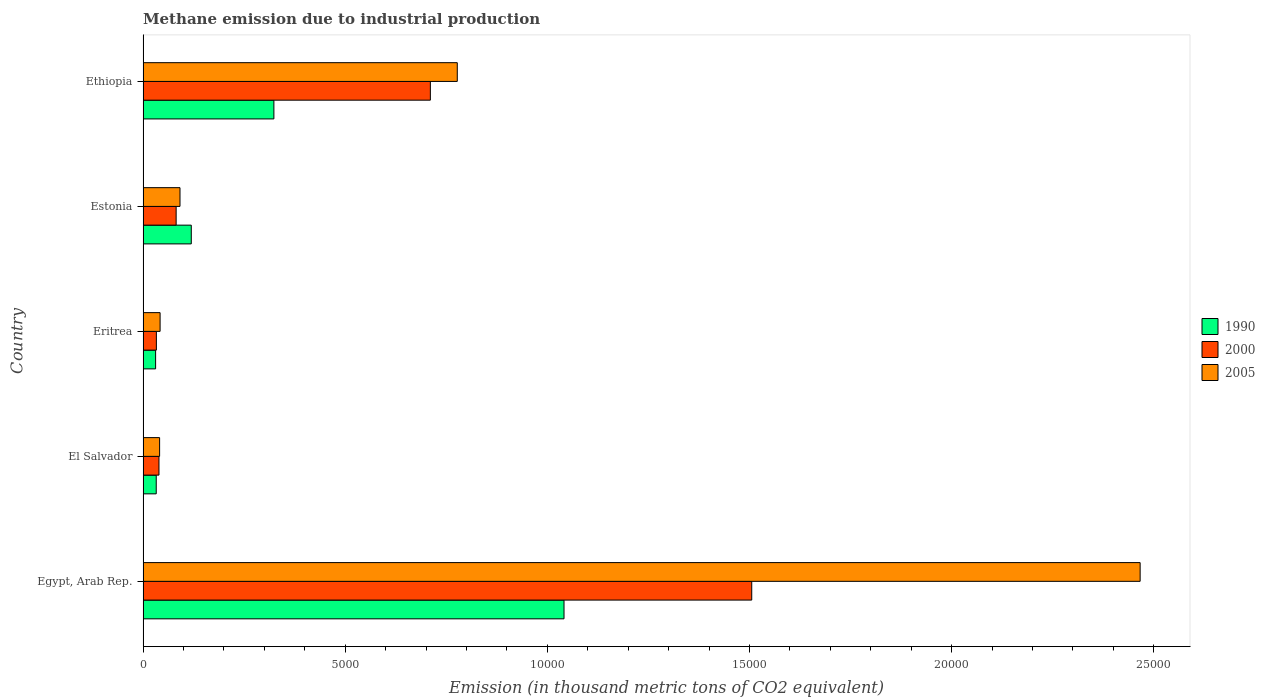How many groups of bars are there?
Your answer should be compact. 5. How many bars are there on the 4th tick from the top?
Offer a very short reply. 3. What is the label of the 4th group of bars from the top?
Provide a short and direct response. El Salvador. In how many cases, is the number of bars for a given country not equal to the number of legend labels?
Make the answer very short. 0. What is the amount of methane emitted in 2000 in Ethiopia?
Offer a very short reply. 7106. Across all countries, what is the maximum amount of methane emitted in 2000?
Provide a succinct answer. 1.51e+04. Across all countries, what is the minimum amount of methane emitted in 2000?
Your answer should be compact. 329.4. In which country was the amount of methane emitted in 1990 maximum?
Provide a short and direct response. Egypt, Arab Rep. In which country was the amount of methane emitted in 2005 minimum?
Offer a very short reply. El Salvador. What is the total amount of methane emitted in 2005 in the graph?
Your response must be concise. 3.42e+04. What is the difference between the amount of methane emitted in 2000 in Egypt, Arab Rep. and that in Eritrea?
Give a very brief answer. 1.47e+04. What is the difference between the amount of methane emitted in 2005 in El Salvador and the amount of methane emitted in 1990 in Eritrea?
Your response must be concise. 98.9. What is the average amount of methane emitted in 1990 per country?
Give a very brief answer. 3095.38. What is the difference between the amount of methane emitted in 2000 and amount of methane emitted in 1990 in Eritrea?
Provide a succinct answer. 19. In how many countries, is the amount of methane emitted in 2000 greater than 19000 thousand metric tons?
Provide a short and direct response. 0. What is the ratio of the amount of methane emitted in 2005 in Egypt, Arab Rep. to that in Eritrea?
Your answer should be compact. 58.52. What is the difference between the highest and the second highest amount of methane emitted in 2000?
Offer a terse response. 7948.9. What is the difference between the highest and the lowest amount of methane emitted in 1990?
Provide a succinct answer. 1.01e+04. In how many countries, is the amount of methane emitted in 2000 greater than the average amount of methane emitted in 2000 taken over all countries?
Your answer should be compact. 2. Is the sum of the amount of methane emitted in 2000 in Egypt, Arab Rep. and Eritrea greater than the maximum amount of methane emitted in 2005 across all countries?
Provide a short and direct response. No. What does the 1st bar from the top in Ethiopia represents?
Ensure brevity in your answer.  2005. Is it the case that in every country, the sum of the amount of methane emitted in 2000 and amount of methane emitted in 2005 is greater than the amount of methane emitted in 1990?
Provide a succinct answer. Yes. How many bars are there?
Your response must be concise. 15. Are all the bars in the graph horizontal?
Give a very brief answer. Yes. Are the values on the major ticks of X-axis written in scientific E-notation?
Your response must be concise. No. Does the graph contain any zero values?
Provide a succinct answer. No. Does the graph contain grids?
Offer a terse response. No. How are the legend labels stacked?
Keep it short and to the point. Vertical. What is the title of the graph?
Offer a terse response. Methane emission due to industrial production. What is the label or title of the X-axis?
Keep it short and to the point. Emission (in thousand metric tons of CO2 equivalent). What is the label or title of the Y-axis?
Keep it short and to the point. Country. What is the Emission (in thousand metric tons of CO2 equivalent) in 1990 in Egypt, Arab Rep.?
Your answer should be very brief. 1.04e+04. What is the Emission (in thousand metric tons of CO2 equivalent) in 2000 in Egypt, Arab Rep.?
Your answer should be compact. 1.51e+04. What is the Emission (in thousand metric tons of CO2 equivalent) in 2005 in Egypt, Arab Rep.?
Keep it short and to the point. 2.47e+04. What is the Emission (in thousand metric tons of CO2 equivalent) in 1990 in El Salvador?
Your answer should be compact. 325.8. What is the Emission (in thousand metric tons of CO2 equivalent) in 2000 in El Salvador?
Your answer should be very brief. 393.6. What is the Emission (in thousand metric tons of CO2 equivalent) in 2005 in El Salvador?
Provide a succinct answer. 409.3. What is the Emission (in thousand metric tons of CO2 equivalent) in 1990 in Eritrea?
Keep it short and to the point. 310.4. What is the Emission (in thousand metric tons of CO2 equivalent) of 2000 in Eritrea?
Your response must be concise. 329.4. What is the Emission (in thousand metric tons of CO2 equivalent) in 2005 in Eritrea?
Ensure brevity in your answer.  421.4. What is the Emission (in thousand metric tons of CO2 equivalent) of 1990 in Estonia?
Make the answer very short. 1192.7. What is the Emission (in thousand metric tons of CO2 equivalent) of 2000 in Estonia?
Offer a very short reply. 818.2. What is the Emission (in thousand metric tons of CO2 equivalent) of 2005 in Estonia?
Your answer should be very brief. 913.5. What is the Emission (in thousand metric tons of CO2 equivalent) of 1990 in Ethiopia?
Make the answer very short. 3236. What is the Emission (in thousand metric tons of CO2 equivalent) in 2000 in Ethiopia?
Offer a very short reply. 7106. What is the Emission (in thousand metric tons of CO2 equivalent) of 2005 in Ethiopia?
Provide a succinct answer. 7772.1. Across all countries, what is the maximum Emission (in thousand metric tons of CO2 equivalent) of 1990?
Give a very brief answer. 1.04e+04. Across all countries, what is the maximum Emission (in thousand metric tons of CO2 equivalent) in 2000?
Keep it short and to the point. 1.51e+04. Across all countries, what is the maximum Emission (in thousand metric tons of CO2 equivalent) in 2005?
Your answer should be very brief. 2.47e+04. Across all countries, what is the minimum Emission (in thousand metric tons of CO2 equivalent) in 1990?
Offer a very short reply. 310.4. Across all countries, what is the minimum Emission (in thousand metric tons of CO2 equivalent) in 2000?
Provide a short and direct response. 329.4. Across all countries, what is the minimum Emission (in thousand metric tons of CO2 equivalent) of 2005?
Your response must be concise. 409.3. What is the total Emission (in thousand metric tons of CO2 equivalent) of 1990 in the graph?
Give a very brief answer. 1.55e+04. What is the total Emission (in thousand metric tons of CO2 equivalent) in 2000 in the graph?
Provide a succinct answer. 2.37e+04. What is the total Emission (in thousand metric tons of CO2 equivalent) of 2005 in the graph?
Give a very brief answer. 3.42e+04. What is the difference between the Emission (in thousand metric tons of CO2 equivalent) of 1990 in Egypt, Arab Rep. and that in El Salvador?
Keep it short and to the point. 1.01e+04. What is the difference between the Emission (in thousand metric tons of CO2 equivalent) in 2000 in Egypt, Arab Rep. and that in El Salvador?
Ensure brevity in your answer.  1.47e+04. What is the difference between the Emission (in thousand metric tons of CO2 equivalent) in 2005 in Egypt, Arab Rep. and that in El Salvador?
Your answer should be compact. 2.43e+04. What is the difference between the Emission (in thousand metric tons of CO2 equivalent) of 1990 in Egypt, Arab Rep. and that in Eritrea?
Your response must be concise. 1.01e+04. What is the difference between the Emission (in thousand metric tons of CO2 equivalent) of 2000 in Egypt, Arab Rep. and that in Eritrea?
Your answer should be compact. 1.47e+04. What is the difference between the Emission (in thousand metric tons of CO2 equivalent) in 2005 in Egypt, Arab Rep. and that in Eritrea?
Give a very brief answer. 2.42e+04. What is the difference between the Emission (in thousand metric tons of CO2 equivalent) in 1990 in Egypt, Arab Rep. and that in Estonia?
Offer a terse response. 9219.3. What is the difference between the Emission (in thousand metric tons of CO2 equivalent) of 2000 in Egypt, Arab Rep. and that in Estonia?
Keep it short and to the point. 1.42e+04. What is the difference between the Emission (in thousand metric tons of CO2 equivalent) of 2005 in Egypt, Arab Rep. and that in Estonia?
Keep it short and to the point. 2.37e+04. What is the difference between the Emission (in thousand metric tons of CO2 equivalent) in 1990 in Egypt, Arab Rep. and that in Ethiopia?
Provide a short and direct response. 7176. What is the difference between the Emission (in thousand metric tons of CO2 equivalent) in 2000 in Egypt, Arab Rep. and that in Ethiopia?
Ensure brevity in your answer.  7948.9. What is the difference between the Emission (in thousand metric tons of CO2 equivalent) in 2005 in Egypt, Arab Rep. and that in Ethiopia?
Provide a succinct answer. 1.69e+04. What is the difference between the Emission (in thousand metric tons of CO2 equivalent) of 1990 in El Salvador and that in Eritrea?
Make the answer very short. 15.4. What is the difference between the Emission (in thousand metric tons of CO2 equivalent) in 2000 in El Salvador and that in Eritrea?
Provide a short and direct response. 64.2. What is the difference between the Emission (in thousand metric tons of CO2 equivalent) of 1990 in El Salvador and that in Estonia?
Offer a terse response. -866.9. What is the difference between the Emission (in thousand metric tons of CO2 equivalent) in 2000 in El Salvador and that in Estonia?
Offer a terse response. -424.6. What is the difference between the Emission (in thousand metric tons of CO2 equivalent) of 2005 in El Salvador and that in Estonia?
Make the answer very short. -504.2. What is the difference between the Emission (in thousand metric tons of CO2 equivalent) in 1990 in El Salvador and that in Ethiopia?
Make the answer very short. -2910.2. What is the difference between the Emission (in thousand metric tons of CO2 equivalent) in 2000 in El Salvador and that in Ethiopia?
Ensure brevity in your answer.  -6712.4. What is the difference between the Emission (in thousand metric tons of CO2 equivalent) in 2005 in El Salvador and that in Ethiopia?
Make the answer very short. -7362.8. What is the difference between the Emission (in thousand metric tons of CO2 equivalent) in 1990 in Eritrea and that in Estonia?
Provide a succinct answer. -882.3. What is the difference between the Emission (in thousand metric tons of CO2 equivalent) of 2000 in Eritrea and that in Estonia?
Give a very brief answer. -488.8. What is the difference between the Emission (in thousand metric tons of CO2 equivalent) in 2005 in Eritrea and that in Estonia?
Your answer should be very brief. -492.1. What is the difference between the Emission (in thousand metric tons of CO2 equivalent) in 1990 in Eritrea and that in Ethiopia?
Your answer should be compact. -2925.6. What is the difference between the Emission (in thousand metric tons of CO2 equivalent) of 2000 in Eritrea and that in Ethiopia?
Keep it short and to the point. -6776.6. What is the difference between the Emission (in thousand metric tons of CO2 equivalent) of 2005 in Eritrea and that in Ethiopia?
Ensure brevity in your answer.  -7350.7. What is the difference between the Emission (in thousand metric tons of CO2 equivalent) in 1990 in Estonia and that in Ethiopia?
Your answer should be compact. -2043.3. What is the difference between the Emission (in thousand metric tons of CO2 equivalent) of 2000 in Estonia and that in Ethiopia?
Give a very brief answer. -6287.8. What is the difference between the Emission (in thousand metric tons of CO2 equivalent) in 2005 in Estonia and that in Ethiopia?
Ensure brevity in your answer.  -6858.6. What is the difference between the Emission (in thousand metric tons of CO2 equivalent) in 1990 in Egypt, Arab Rep. and the Emission (in thousand metric tons of CO2 equivalent) in 2000 in El Salvador?
Your response must be concise. 1.00e+04. What is the difference between the Emission (in thousand metric tons of CO2 equivalent) in 1990 in Egypt, Arab Rep. and the Emission (in thousand metric tons of CO2 equivalent) in 2005 in El Salvador?
Your answer should be compact. 1.00e+04. What is the difference between the Emission (in thousand metric tons of CO2 equivalent) of 2000 in Egypt, Arab Rep. and the Emission (in thousand metric tons of CO2 equivalent) of 2005 in El Salvador?
Offer a terse response. 1.46e+04. What is the difference between the Emission (in thousand metric tons of CO2 equivalent) in 1990 in Egypt, Arab Rep. and the Emission (in thousand metric tons of CO2 equivalent) in 2000 in Eritrea?
Offer a terse response. 1.01e+04. What is the difference between the Emission (in thousand metric tons of CO2 equivalent) of 1990 in Egypt, Arab Rep. and the Emission (in thousand metric tons of CO2 equivalent) of 2005 in Eritrea?
Provide a short and direct response. 9990.6. What is the difference between the Emission (in thousand metric tons of CO2 equivalent) in 2000 in Egypt, Arab Rep. and the Emission (in thousand metric tons of CO2 equivalent) in 2005 in Eritrea?
Offer a terse response. 1.46e+04. What is the difference between the Emission (in thousand metric tons of CO2 equivalent) in 1990 in Egypt, Arab Rep. and the Emission (in thousand metric tons of CO2 equivalent) in 2000 in Estonia?
Ensure brevity in your answer.  9593.8. What is the difference between the Emission (in thousand metric tons of CO2 equivalent) of 1990 in Egypt, Arab Rep. and the Emission (in thousand metric tons of CO2 equivalent) of 2005 in Estonia?
Your response must be concise. 9498.5. What is the difference between the Emission (in thousand metric tons of CO2 equivalent) of 2000 in Egypt, Arab Rep. and the Emission (in thousand metric tons of CO2 equivalent) of 2005 in Estonia?
Give a very brief answer. 1.41e+04. What is the difference between the Emission (in thousand metric tons of CO2 equivalent) of 1990 in Egypt, Arab Rep. and the Emission (in thousand metric tons of CO2 equivalent) of 2000 in Ethiopia?
Your answer should be very brief. 3306. What is the difference between the Emission (in thousand metric tons of CO2 equivalent) of 1990 in Egypt, Arab Rep. and the Emission (in thousand metric tons of CO2 equivalent) of 2005 in Ethiopia?
Make the answer very short. 2639.9. What is the difference between the Emission (in thousand metric tons of CO2 equivalent) of 2000 in Egypt, Arab Rep. and the Emission (in thousand metric tons of CO2 equivalent) of 2005 in Ethiopia?
Your answer should be very brief. 7282.8. What is the difference between the Emission (in thousand metric tons of CO2 equivalent) in 1990 in El Salvador and the Emission (in thousand metric tons of CO2 equivalent) in 2005 in Eritrea?
Your response must be concise. -95.6. What is the difference between the Emission (in thousand metric tons of CO2 equivalent) in 2000 in El Salvador and the Emission (in thousand metric tons of CO2 equivalent) in 2005 in Eritrea?
Ensure brevity in your answer.  -27.8. What is the difference between the Emission (in thousand metric tons of CO2 equivalent) of 1990 in El Salvador and the Emission (in thousand metric tons of CO2 equivalent) of 2000 in Estonia?
Give a very brief answer. -492.4. What is the difference between the Emission (in thousand metric tons of CO2 equivalent) in 1990 in El Salvador and the Emission (in thousand metric tons of CO2 equivalent) in 2005 in Estonia?
Keep it short and to the point. -587.7. What is the difference between the Emission (in thousand metric tons of CO2 equivalent) in 2000 in El Salvador and the Emission (in thousand metric tons of CO2 equivalent) in 2005 in Estonia?
Your answer should be very brief. -519.9. What is the difference between the Emission (in thousand metric tons of CO2 equivalent) of 1990 in El Salvador and the Emission (in thousand metric tons of CO2 equivalent) of 2000 in Ethiopia?
Make the answer very short. -6780.2. What is the difference between the Emission (in thousand metric tons of CO2 equivalent) in 1990 in El Salvador and the Emission (in thousand metric tons of CO2 equivalent) in 2005 in Ethiopia?
Provide a succinct answer. -7446.3. What is the difference between the Emission (in thousand metric tons of CO2 equivalent) of 2000 in El Salvador and the Emission (in thousand metric tons of CO2 equivalent) of 2005 in Ethiopia?
Provide a short and direct response. -7378.5. What is the difference between the Emission (in thousand metric tons of CO2 equivalent) in 1990 in Eritrea and the Emission (in thousand metric tons of CO2 equivalent) in 2000 in Estonia?
Your response must be concise. -507.8. What is the difference between the Emission (in thousand metric tons of CO2 equivalent) in 1990 in Eritrea and the Emission (in thousand metric tons of CO2 equivalent) in 2005 in Estonia?
Your answer should be compact. -603.1. What is the difference between the Emission (in thousand metric tons of CO2 equivalent) of 2000 in Eritrea and the Emission (in thousand metric tons of CO2 equivalent) of 2005 in Estonia?
Keep it short and to the point. -584.1. What is the difference between the Emission (in thousand metric tons of CO2 equivalent) of 1990 in Eritrea and the Emission (in thousand metric tons of CO2 equivalent) of 2000 in Ethiopia?
Provide a succinct answer. -6795.6. What is the difference between the Emission (in thousand metric tons of CO2 equivalent) in 1990 in Eritrea and the Emission (in thousand metric tons of CO2 equivalent) in 2005 in Ethiopia?
Keep it short and to the point. -7461.7. What is the difference between the Emission (in thousand metric tons of CO2 equivalent) in 2000 in Eritrea and the Emission (in thousand metric tons of CO2 equivalent) in 2005 in Ethiopia?
Your response must be concise. -7442.7. What is the difference between the Emission (in thousand metric tons of CO2 equivalent) of 1990 in Estonia and the Emission (in thousand metric tons of CO2 equivalent) of 2000 in Ethiopia?
Keep it short and to the point. -5913.3. What is the difference between the Emission (in thousand metric tons of CO2 equivalent) in 1990 in Estonia and the Emission (in thousand metric tons of CO2 equivalent) in 2005 in Ethiopia?
Make the answer very short. -6579.4. What is the difference between the Emission (in thousand metric tons of CO2 equivalent) of 2000 in Estonia and the Emission (in thousand metric tons of CO2 equivalent) of 2005 in Ethiopia?
Provide a short and direct response. -6953.9. What is the average Emission (in thousand metric tons of CO2 equivalent) in 1990 per country?
Provide a short and direct response. 3095.38. What is the average Emission (in thousand metric tons of CO2 equivalent) in 2000 per country?
Provide a short and direct response. 4740.42. What is the average Emission (in thousand metric tons of CO2 equivalent) in 2005 per country?
Your answer should be very brief. 6835.64. What is the difference between the Emission (in thousand metric tons of CO2 equivalent) of 1990 and Emission (in thousand metric tons of CO2 equivalent) of 2000 in Egypt, Arab Rep.?
Offer a terse response. -4642.9. What is the difference between the Emission (in thousand metric tons of CO2 equivalent) of 1990 and Emission (in thousand metric tons of CO2 equivalent) of 2005 in Egypt, Arab Rep.?
Make the answer very short. -1.42e+04. What is the difference between the Emission (in thousand metric tons of CO2 equivalent) in 2000 and Emission (in thousand metric tons of CO2 equivalent) in 2005 in Egypt, Arab Rep.?
Keep it short and to the point. -9607. What is the difference between the Emission (in thousand metric tons of CO2 equivalent) of 1990 and Emission (in thousand metric tons of CO2 equivalent) of 2000 in El Salvador?
Your answer should be very brief. -67.8. What is the difference between the Emission (in thousand metric tons of CO2 equivalent) in 1990 and Emission (in thousand metric tons of CO2 equivalent) in 2005 in El Salvador?
Your answer should be very brief. -83.5. What is the difference between the Emission (in thousand metric tons of CO2 equivalent) in 2000 and Emission (in thousand metric tons of CO2 equivalent) in 2005 in El Salvador?
Give a very brief answer. -15.7. What is the difference between the Emission (in thousand metric tons of CO2 equivalent) in 1990 and Emission (in thousand metric tons of CO2 equivalent) in 2000 in Eritrea?
Give a very brief answer. -19. What is the difference between the Emission (in thousand metric tons of CO2 equivalent) of 1990 and Emission (in thousand metric tons of CO2 equivalent) of 2005 in Eritrea?
Your answer should be very brief. -111. What is the difference between the Emission (in thousand metric tons of CO2 equivalent) of 2000 and Emission (in thousand metric tons of CO2 equivalent) of 2005 in Eritrea?
Your response must be concise. -92. What is the difference between the Emission (in thousand metric tons of CO2 equivalent) of 1990 and Emission (in thousand metric tons of CO2 equivalent) of 2000 in Estonia?
Your answer should be very brief. 374.5. What is the difference between the Emission (in thousand metric tons of CO2 equivalent) in 1990 and Emission (in thousand metric tons of CO2 equivalent) in 2005 in Estonia?
Offer a very short reply. 279.2. What is the difference between the Emission (in thousand metric tons of CO2 equivalent) in 2000 and Emission (in thousand metric tons of CO2 equivalent) in 2005 in Estonia?
Make the answer very short. -95.3. What is the difference between the Emission (in thousand metric tons of CO2 equivalent) in 1990 and Emission (in thousand metric tons of CO2 equivalent) in 2000 in Ethiopia?
Your answer should be very brief. -3870. What is the difference between the Emission (in thousand metric tons of CO2 equivalent) in 1990 and Emission (in thousand metric tons of CO2 equivalent) in 2005 in Ethiopia?
Provide a succinct answer. -4536.1. What is the difference between the Emission (in thousand metric tons of CO2 equivalent) of 2000 and Emission (in thousand metric tons of CO2 equivalent) of 2005 in Ethiopia?
Make the answer very short. -666.1. What is the ratio of the Emission (in thousand metric tons of CO2 equivalent) of 1990 in Egypt, Arab Rep. to that in El Salvador?
Ensure brevity in your answer.  31.96. What is the ratio of the Emission (in thousand metric tons of CO2 equivalent) of 2000 in Egypt, Arab Rep. to that in El Salvador?
Ensure brevity in your answer.  38.25. What is the ratio of the Emission (in thousand metric tons of CO2 equivalent) in 2005 in Egypt, Arab Rep. to that in El Salvador?
Offer a very short reply. 60.25. What is the ratio of the Emission (in thousand metric tons of CO2 equivalent) of 1990 in Egypt, Arab Rep. to that in Eritrea?
Ensure brevity in your answer.  33.54. What is the ratio of the Emission (in thousand metric tons of CO2 equivalent) in 2000 in Egypt, Arab Rep. to that in Eritrea?
Give a very brief answer. 45.7. What is the ratio of the Emission (in thousand metric tons of CO2 equivalent) of 2005 in Egypt, Arab Rep. to that in Eritrea?
Your answer should be compact. 58.52. What is the ratio of the Emission (in thousand metric tons of CO2 equivalent) of 1990 in Egypt, Arab Rep. to that in Estonia?
Ensure brevity in your answer.  8.73. What is the ratio of the Emission (in thousand metric tons of CO2 equivalent) in 2000 in Egypt, Arab Rep. to that in Estonia?
Your answer should be very brief. 18.4. What is the ratio of the Emission (in thousand metric tons of CO2 equivalent) in 2005 in Egypt, Arab Rep. to that in Estonia?
Offer a very short reply. 27. What is the ratio of the Emission (in thousand metric tons of CO2 equivalent) of 1990 in Egypt, Arab Rep. to that in Ethiopia?
Provide a short and direct response. 3.22. What is the ratio of the Emission (in thousand metric tons of CO2 equivalent) in 2000 in Egypt, Arab Rep. to that in Ethiopia?
Make the answer very short. 2.12. What is the ratio of the Emission (in thousand metric tons of CO2 equivalent) of 2005 in Egypt, Arab Rep. to that in Ethiopia?
Your answer should be compact. 3.17. What is the ratio of the Emission (in thousand metric tons of CO2 equivalent) in 1990 in El Salvador to that in Eritrea?
Ensure brevity in your answer.  1.05. What is the ratio of the Emission (in thousand metric tons of CO2 equivalent) in 2000 in El Salvador to that in Eritrea?
Offer a terse response. 1.19. What is the ratio of the Emission (in thousand metric tons of CO2 equivalent) of 2005 in El Salvador to that in Eritrea?
Keep it short and to the point. 0.97. What is the ratio of the Emission (in thousand metric tons of CO2 equivalent) in 1990 in El Salvador to that in Estonia?
Offer a terse response. 0.27. What is the ratio of the Emission (in thousand metric tons of CO2 equivalent) in 2000 in El Salvador to that in Estonia?
Your answer should be very brief. 0.48. What is the ratio of the Emission (in thousand metric tons of CO2 equivalent) of 2005 in El Salvador to that in Estonia?
Give a very brief answer. 0.45. What is the ratio of the Emission (in thousand metric tons of CO2 equivalent) in 1990 in El Salvador to that in Ethiopia?
Your response must be concise. 0.1. What is the ratio of the Emission (in thousand metric tons of CO2 equivalent) of 2000 in El Salvador to that in Ethiopia?
Your answer should be compact. 0.06. What is the ratio of the Emission (in thousand metric tons of CO2 equivalent) in 2005 in El Salvador to that in Ethiopia?
Give a very brief answer. 0.05. What is the ratio of the Emission (in thousand metric tons of CO2 equivalent) in 1990 in Eritrea to that in Estonia?
Offer a very short reply. 0.26. What is the ratio of the Emission (in thousand metric tons of CO2 equivalent) of 2000 in Eritrea to that in Estonia?
Ensure brevity in your answer.  0.4. What is the ratio of the Emission (in thousand metric tons of CO2 equivalent) of 2005 in Eritrea to that in Estonia?
Ensure brevity in your answer.  0.46. What is the ratio of the Emission (in thousand metric tons of CO2 equivalent) in 1990 in Eritrea to that in Ethiopia?
Your answer should be compact. 0.1. What is the ratio of the Emission (in thousand metric tons of CO2 equivalent) in 2000 in Eritrea to that in Ethiopia?
Your answer should be very brief. 0.05. What is the ratio of the Emission (in thousand metric tons of CO2 equivalent) in 2005 in Eritrea to that in Ethiopia?
Provide a short and direct response. 0.05. What is the ratio of the Emission (in thousand metric tons of CO2 equivalent) of 1990 in Estonia to that in Ethiopia?
Offer a very short reply. 0.37. What is the ratio of the Emission (in thousand metric tons of CO2 equivalent) of 2000 in Estonia to that in Ethiopia?
Your answer should be compact. 0.12. What is the ratio of the Emission (in thousand metric tons of CO2 equivalent) in 2005 in Estonia to that in Ethiopia?
Offer a terse response. 0.12. What is the difference between the highest and the second highest Emission (in thousand metric tons of CO2 equivalent) of 1990?
Your answer should be compact. 7176. What is the difference between the highest and the second highest Emission (in thousand metric tons of CO2 equivalent) in 2000?
Provide a short and direct response. 7948.9. What is the difference between the highest and the second highest Emission (in thousand metric tons of CO2 equivalent) in 2005?
Provide a short and direct response. 1.69e+04. What is the difference between the highest and the lowest Emission (in thousand metric tons of CO2 equivalent) of 1990?
Your answer should be compact. 1.01e+04. What is the difference between the highest and the lowest Emission (in thousand metric tons of CO2 equivalent) in 2000?
Your answer should be compact. 1.47e+04. What is the difference between the highest and the lowest Emission (in thousand metric tons of CO2 equivalent) of 2005?
Make the answer very short. 2.43e+04. 